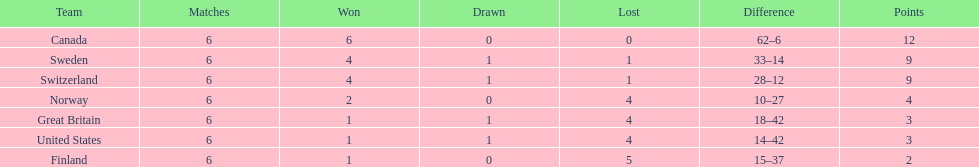What team placed after canada? Sweden. 